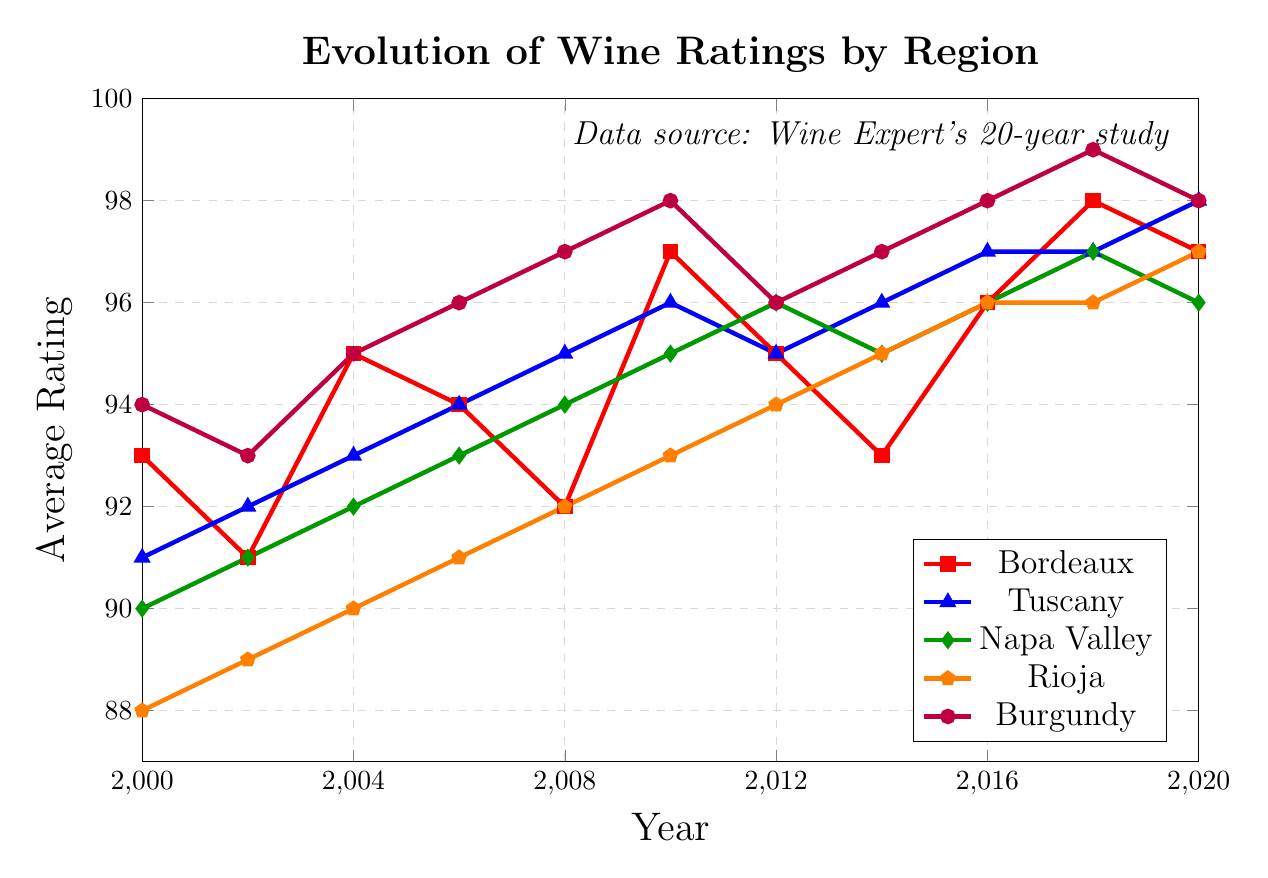What's the average rating of Napa Valley in the years displayed? Add the ratings for Napa Valley (90 + 91 + 92 + 93 + 94 + 95 + 96 + 95 + 96 + 97 + 96) and divide by the number of years (11). The sum is 1030, so the average is 1030/11.
Answer: 93.64 Which wine region experienced the highest rating increase from 2000 to 2020? Compare the difference in ratings between 2020 and 2000 for all regions: Bordeaux (97 - 93 = 4), Tuscany (98 - 91 = 7), Napa Valley (96 - 90 = 6), Rioja (97 - 88 = 9), Burgundy (98 - 94 = 4). Rioja had the highest increase of 9 points.
Answer: Rioja In which year did Burgundy receive its highest rating? Examine the ratings for Burgundy and identify the year with the highest value. Burgundy received its highest rating of 99 in 2018.
Answer: 2018 Compare Bordeaux and Tuscany: Which region had higher ratings in more years? Count the number of years Bordeaux had higher ratings than Tuscany and vice versa: Bordeaux (2000, 2004, 2006, 2010, 2012, 2016, 2018), Tuscany (2002, 2008, 2014, 2020). Bordeaux had higher ratings in 7 years compared to 4 for Tuscany.
Answer: Bordeaux What is the difference between the highest and lowest ratings for Rioja over the years? Identify the highest (97 in 2020) and lowest (88 in 2000) ratings for Rioja, then compute the difference (97 - 88 = 9).
Answer: 9 In which year did all five regions have ratings above 95? Look for the year where every region has ratings above 95: Bordeaux (96), Tuscany (97), Napa Valley (96), Rioja (96), Burgundy (98) in 2016, 2018, and 2020.
Answer: 2016, 2018, 2020 By how many points did the rating of Tuscany increase from 2000 to 2008? Calculate the difference in Tuscany's ratings from 2000 to 2008 (95 - 91 = 4).
Answer: 4 Which region has the most consistent ratings over the period (smallest variation)? Calculate the range (maximum - minimum ratings) for each region: Bordeaux (98 - 91 = 7), Tuscany (98 - 91 = 7), Napa Valley (97 - 90 = 7), Rioja (97 - 88 = 9), Burgundy (99 - 93 = 6). Burgundy has the smallest variation at 6 points.
Answer: Burgundy 